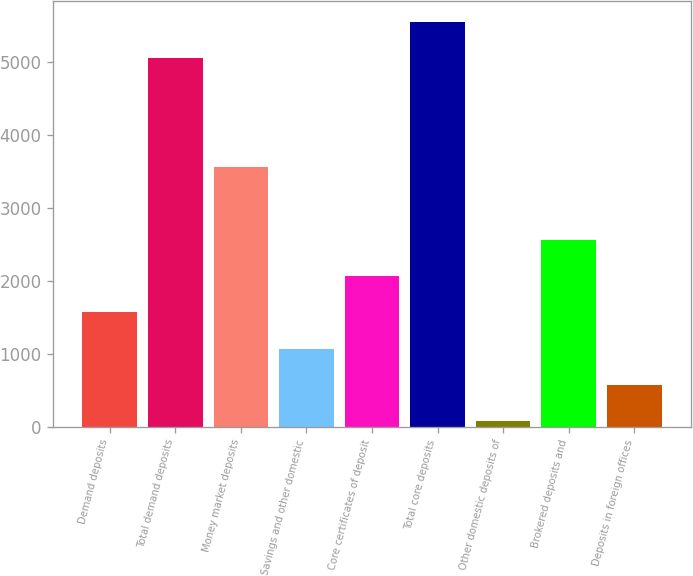Convert chart. <chart><loc_0><loc_0><loc_500><loc_500><bar_chart><fcel>Demand deposits<fcel>Total demand deposits<fcel>Money market deposits<fcel>Savings and other domestic<fcel>Core certificates of deposit<fcel>Total core deposits<fcel>Other domestic deposits of<fcel>Brokered deposits and<fcel>Deposits in foreign offices<nl><fcel>1567.1<fcel>5051<fcel>3557.9<fcel>1069.4<fcel>2064.8<fcel>5548.7<fcel>74<fcel>2562.5<fcel>571.7<nl></chart> 